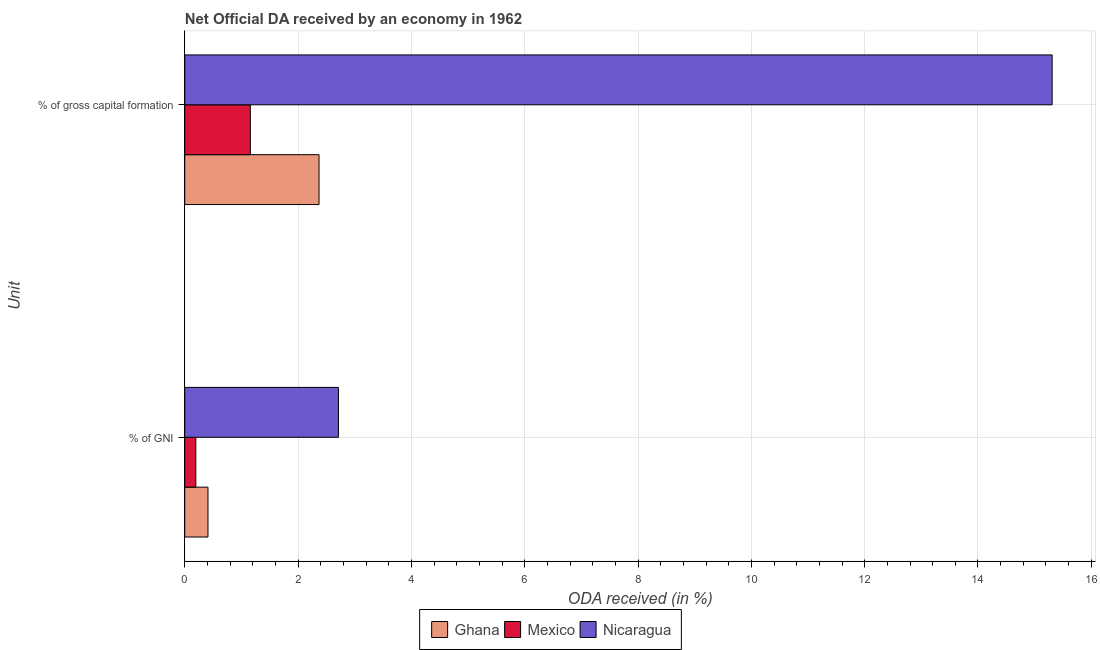Are the number of bars per tick equal to the number of legend labels?
Offer a terse response. Yes. What is the label of the 2nd group of bars from the top?
Keep it short and to the point. % of GNI. What is the oda received as percentage of gni in Nicaragua?
Your answer should be compact. 2.71. Across all countries, what is the maximum oda received as percentage of gross capital formation?
Your answer should be very brief. 15.31. Across all countries, what is the minimum oda received as percentage of gni?
Your response must be concise. 0.2. In which country was the oda received as percentage of gross capital formation maximum?
Offer a terse response. Nicaragua. In which country was the oda received as percentage of gni minimum?
Your answer should be very brief. Mexico. What is the total oda received as percentage of gni in the graph?
Your answer should be compact. 3.32. What is the difference between the oda received as percentage of gross capital formation in Mexico and that in Ghana?
Offer a very short reply. -1.21. What is the difference between the oda received as percentage of gross capital formation in Ghana and the oda received as percentage of gni in Mexico?
Give a very brief answer. 2.17. What is the average oda received as percentage of gross capital formation per country?
Your answer should be very brief. 6.28. What is the difference between the oda received as percentage of gni and oda received as percentage of gross capital formation in Ghana?
Offer a terse response. -1.96. In how many countries, is the oda received as percentage of gross capital formation greater than 14.8 %?
Ensure brevity in your answer.  1. What is the ratio of the oda received as percentage of gni in Mexico to that in Nicaragua?
Your answer should be very brief. 0.07. Is the oda received as percentage of gni in Nicaragua less than that in Ghana?
Make the answer very short. No. What does the 1st bar from the top in % of gross capital formation represents?
Provide a short and direct response. Nicaragua. What does the 3rd bar from the bottom in % of GNI represents?
Provide a short and direct response. Nicaragua. How many countries are there in the graph?
Keep it short and to the point. 3. What is the difference between two consecutive major ticks on the X-axis?
Your answer should be compact. 2. Where does the legend appear in the graph?
Provide a short and direct response. Bottom center. How many legend labels are there?
Make the answer very short. 3. What is the title of the graph?
Ensure brevity in your answer.  Net Official DA received by an economy in 1962. What is the label or title of the X-axis?
Make the answer very short. ODA received (in %). What is the label or title of the Y-axis?
Ensure brevity in your answer.  Unit. What is the ODA received (in %) of Ghana in % of GNI?
Give a very brief answer. 0.41. What is the ODA received (in %) of Mexico in % of GNI?
Your answer should be very brief. 0.2. What is the ODA received (in %) in Nicaragua in % of GNI?
Your answer should be compact. 2.71. What is the ODA received (in %) in Ghana in % of gross capital formation?
Provide a succinct answer. 2.37. What is the ODA received (in %) of Mexico in % of gross capital formation?
Offer a very short reply. 1.16. What is the ODA received (in %) of Nicaragua in % of gross capital formation?
Ensure brevity in your answer.  15.31. Across all Unit, what is the maximum ODA received (in %) of Ghana?
Give a very brief answer. 2.37. Across all Unit, what is the maximum ODA received (in %) in Mexico?
Make the answer very short. 1.16. Across all Unit, what is the maximum ODA received (in %) in Nicaragua?
Your answer should be compact. 15.31. Across all Unit, what is the minimum ODA received (in %) of Ghana?
Your answer should be very brief. 0.41. Across all Unit, what is the minimum ODA received (in %) in Mexico?
Give a very brief answer. 0.2. Across all Unit, what is the minimum ODA received (in %) in Nicaragua?
Keep it short and to the point. 2.71. What is the total ODA received (in %) in Ghana in the graph?
Provide a succinct answer. 2.78. What is the total ODA received (in %) in Mexico in the graph?
Keep it short and to the point. 1.35. What is the total ODA received (in %) of Nicaragua in the graph?
Provide a succinct answer. 18.02. What is the difference between the ODA received (in %) in Ghana in % of GNI and that in % of gross capital formation?
Provide a short and direct response. -1.96. What is the difference between the ODA received (in %) in Mexico in % of GNI and that in % of gross capital formation?
Provide a succinct answer. -0.96. What is the difference between the ODA received (in %) in Nicaragua in % of GNI and that in % of gross capital formation?
Ensure brevity in your answer.  -12.6. What is the difference between the ODA received (in %) in Ghana in % of GNI and the ODA received (in %) in Mexico in % of gross capital formation?
Offer a terse response. -0.75. What is the difference between the ODA received (in %) in Ghana in % of GNI and the ODA received (in %) in Nicaragua in % of gross capital formation?
Provide a short and direct response. -14.9. What is the difference between the ODA received (in %) in Mexico in % of GNI and the ODA received (in %) in Nicaragua in % of gross capital formation?
Your response must be concise. -15.11. What is the average ODA received (in %) in Ghana per Unit?
Provide a short and direct response. 1.39. What is the average ODA received (in %) in Mexico per Unit?
Provide a succinct answer. 0.68. What is the average ODA received (in %) of Nicaragua per Unit?
Ensure brevity in your answer.  9.01. What is the difference between the ODA received (in %) in Ghana and ODA received (in %) in Mexico in % of GNI?
Make the answer very short. 0.21. What is the difference between the ODA received (in %) of Ghana and ODA received (in %) of Nicaragua in % of GNI?
Make the answer very short. -2.3. What is the difference between the ODA received (in %) of Mexico and ODA received (in %) of Nicaragua in % of GNI?
Your response must be concise. -2.52. What is the difference between the ODA received (in %) in Ghana and ODA received (in %) in Mexico in % of gross capital formation?
Ensure brevity in your answer.  1.21. What is the difference between the ODA received (in %) of Ghana and ODA received (in %) of Nicaragua in % of gross capital formation?
Keep it short and to the point. -12.94. What is the difference between the ODA received (in %) in Mexico and ODA received (in %) in Nicaragua in % of gross capital formation?
Provide a short and direct response. -14.15. What is the ratio of the ODA received (in %) of Ghana in % of GNI to that in % of gross capital formation?
Provide a succinct answer. 0.17. What is the ratio of the ODA received (in %) of Mexico in % of GNI to that in % of gross capital formation?
Keep it short and to the point. 0.17. What is the ratio of the ODA received (in %) in Nicaragua in % of GNI to that in % of gross capital formation?
Offer a terse response. 0.18. What is the difference between the highest and the second highest ODA received (in %) of Ghana?
Offer a very short reply. 1.96. What is the difference between the highest and the second highest ODA received (in %) of Nicaragua?
Provide a succinct answer. 12.6. What is the difference between the highest and the lowest ODA received (in %) in Ghana?
Give a very brief answer. 1.96. What is the difference between the highest and the lowest ODA received (in %) in Mexico?
Offer a very short reply. 0.96. What is the difference between the highest and the lowest ODA received (in %) of Nicaragua?
Your answer should be compact. 12.6. 